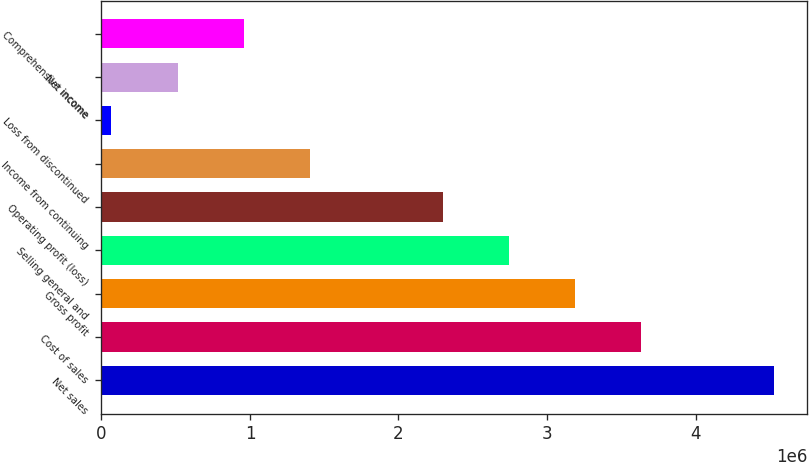Convert chart to OTSL. <chart><loc_0><loc_0><loc_500><loc_500><bar_chart><fcel>Net sales<fcel>Cost of sales<fcel>Gross profit<fcel>Selling general and<fcel>Operating profit (loss)<fcel>Income from continuing<fcel>Loss from discontinued<fcel>Net income<fcel>Comprehensive income<nl><fcel>4.52572e+06<fcel>3.63413e+06<fcel>3.18833e+06<fcel>2.74254e+06<fcel>2.29674e+06<fcel>1.40515e+06<fcel>67762<fcel>513558<fcel>959354<nl></chart> 